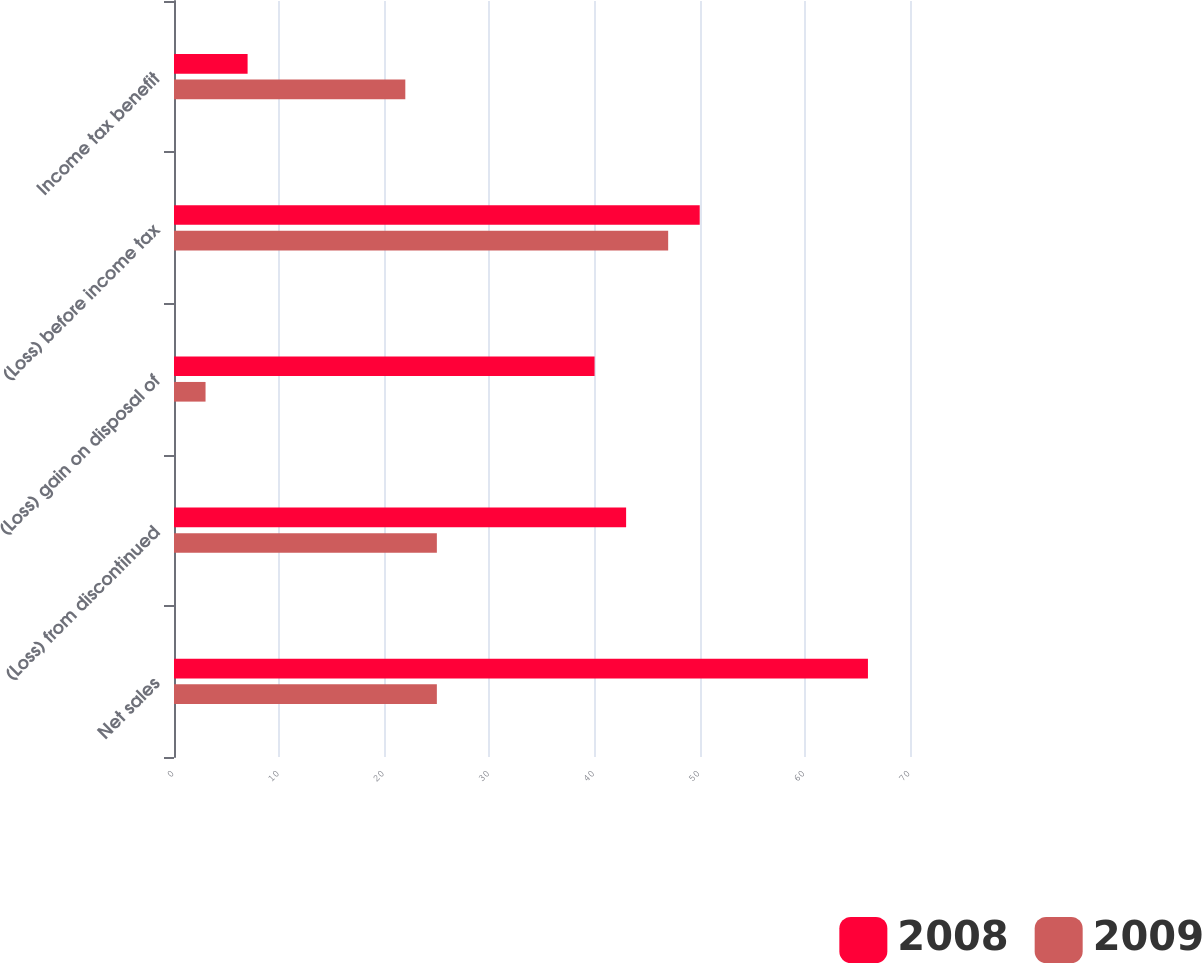<chart> <loc_0><loc_0><loc_500><loc_500><stacked_bar_chart><ecel><fcel>Net sales<fcel>(Loss) from discontinued<fcel>(Loss) gain on disposal of<fcel>(Loss) before income tax<fcel>Income tax benefit<nl><fcel>2008<fcel>66<fcel>43<fcel>40<fcel>50<fcel>7<nl><fcel>2009<fcel>25<fcel>25<fcel>3<fcel>47<fcel>22<nl></chart> 